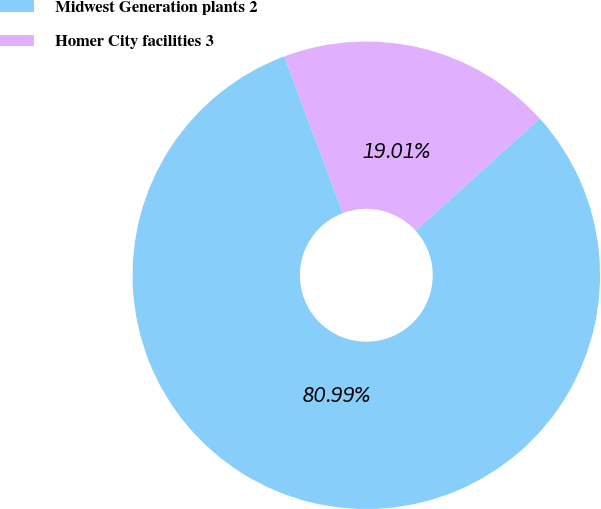<chart> <loc_0><loc_0><loc_500><loc_500><pie_chart><fcel>Midwest Generation plants 2<fcel>Homer City facilities 3<nl><fcel>80.99%<fcel>19.01%<nl></chart> 